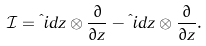<formula> <loc_0><loc_0><loc_500><loc_500>\mathcal { I } = \i i d z \otimes \frac { \partial } { \partial z } - \i i d \bar { z } \otimes \frac { \partial } { \partial \bar { z } } .</formula> 